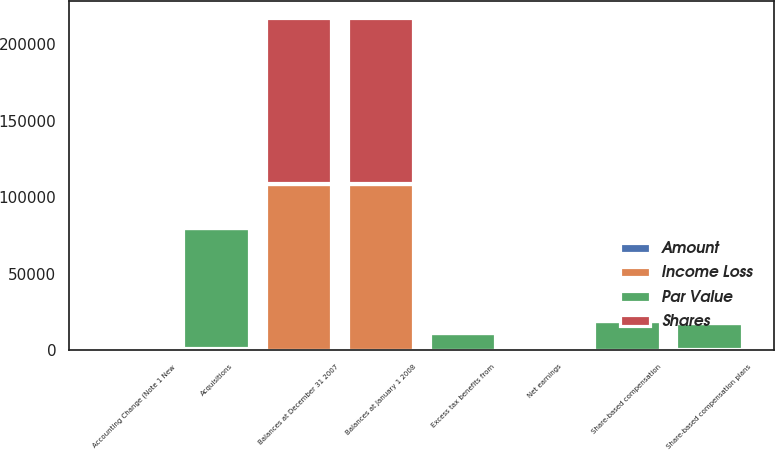Convert chart. <chart><loc_0><loc_0><loc_500><loc_500><stacked_bar_chart><ecel><fcel>Balances at December 31 2007<fcel>Accounting Change (Note 1 New<fcel>Balances at January 1 2008<fcel>Net earnings<fcel>Acquisitions<fcel>Share-based compensation plans<fcel>Share-based compensation<fcel>Excess tax benefits from<nl><fcel>Shares<fcel>108234<fcel>0<fcel>108234<fcel>0<fcel>1152<fcel>884<fcel>0<fcel>0<nl><fcel>Income Loss<fcel>108234<fcel>0<fcel>108234<fcel>0<fcel>1152<fcel>884<fcel>0<fcel>0<nl><fcel>Par Value<fcel>442<fcel>0<fcel>442<fcel>0<fcel>78948<fcel>17130<fcel>19096<fcel>11209<nl><fcel>Amount<fcel>442<fcel>1312<fcel>442<fcel>918<fcel>0<fcel>0<fcel>0<fcel>0<nl></chart> 